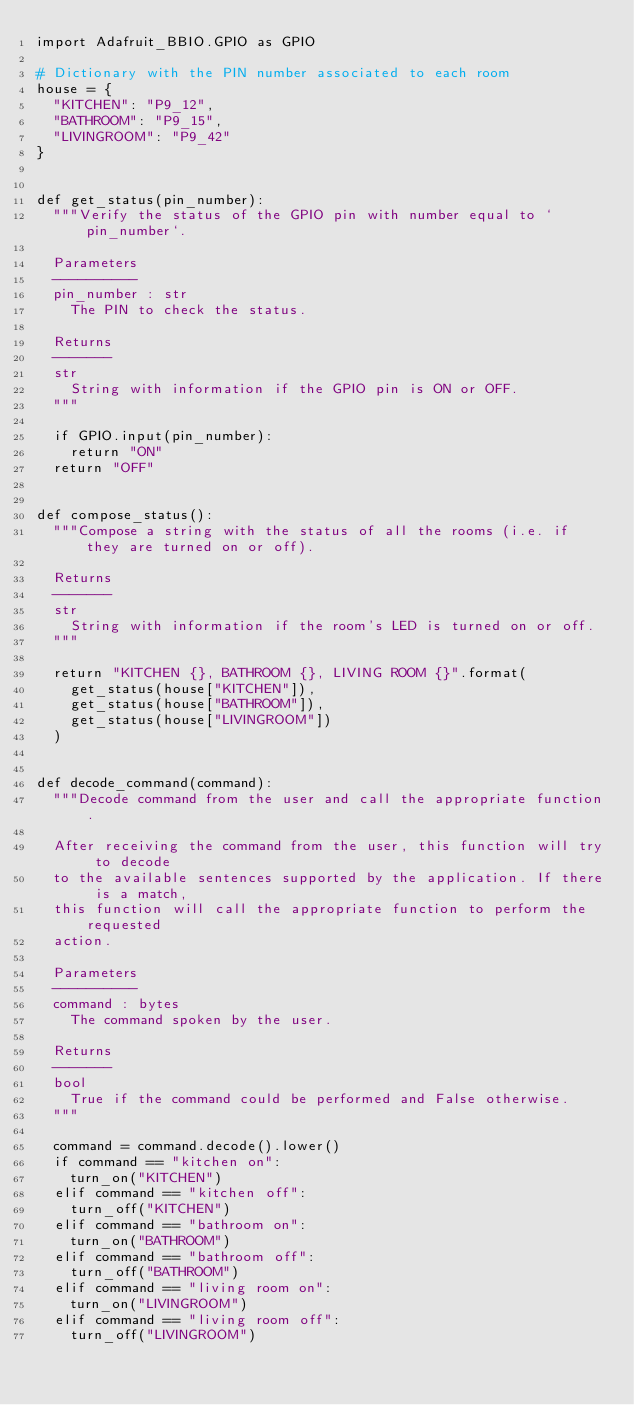Convert code to text. <code><loc_0><loc_0><loc_500><loc_500><_Python_>import Adafruit_BBIO.GPIO as GPIO

# Dictionary with the PIN number associated to each room
house = {
	"KITCHEN": "P9_12",
	"BATHROOM": "P9_15",
	"LIVINGROOM": "P9_42"
}


def get_status(pin_number):
	"""Verify the status of the GPIO pin with number equal to `pin_number`.

	Parameters
	----------
	pin_number : str
		The PIN to check the status.

	Returns
	-------
	str
		String with information if the GPIO pin is ON or OFF.
	"""

	if GPIO.input(pin_number):
		return "ON"
	return "OFF"


def compose_status():
	"""Compose a string with the status of all the rooms (i.e. if they are turned on or off).

	Returns
	-------
	str
		String with information if the room's LED is turned on or off.
	"""

	return "KITCHEN {}, BATHROOM {}, LIVING ROOM {}".format(
		get_status(house["KITCHEN"]),
		get_status(house["BATHROOM"]),
		get_status(house["LIVINGROOM"])
	)


def decode_command(command):
	"""Decode command from the user and call the appropriate function.

	After receiving the command from the user, this function will try to decode
	to the available sentences supported by the application. If there is a match,
	this function will call the appropriate function to perform the requested
	action.

	Parameters
	----------
	command : bytes
		The command spoken by the user.

	Returns
	-------
	bool
		True if the command could be performed and False otherwise.
	"""

	command = command.decode().lower()
	if command == "kitchen on":
		turn_on("KITCHEN")
	elif command == "kitchen off":
		turn_off("KITCHEN")
	elif command == "bathroom on":
		turn_on("BATHROOM")
	elif command == "bathroom off":
		turn_off("BATHROOM")
	elif command == "living room on":
		turn_on("LIVINGROOM")
	elif command == "living room off":
		turn_off("LIVINGROOM")</code> 